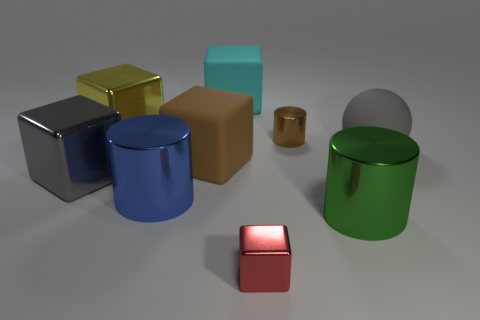Subtract all cyan matte blocks. How many blocks are left? 4 Subtract all gray blocks. How many blocks are left? 4 Add 4 big brown rubber objects. How many big brown rubber objects are left? 5 Add 2 brown things. How many brown things exist? 4 Add 1 big brown spheres. How many objects exist? 10 Subtract 0 purple cylinders. How many objects are left? 9 Subtract all blocks. How many objects are left? 4 Subtract 2 blocks. How many blocks are left? 3 Subtract all blue cylinders. Subtract all cyan balls. How many cylinders are left? 2 Subtract all red balls. How many red cylinders are left? 0 